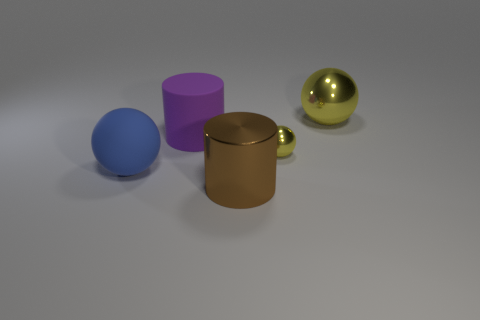What possible real-world sizes could these objects have, judging by their appearance? The objects could be small handheld props, with the spheres being the size of marbles or baubles and the cylinder similar to a cup in diameter. The absence of a reference object makes it challenging to ascertain their absolute size, but they seem designed to be portable rather than massive. 